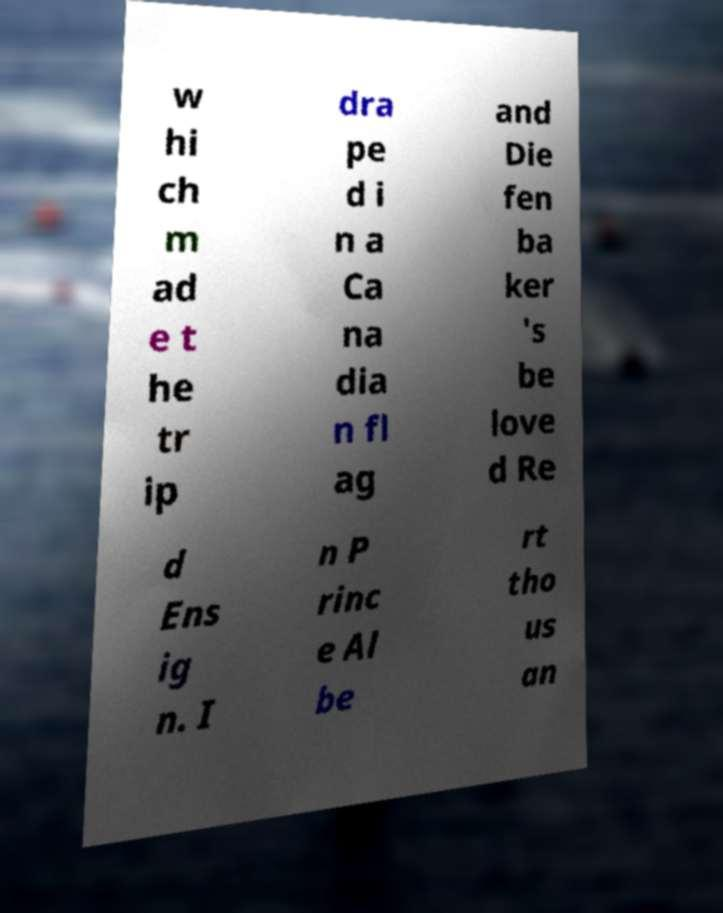Please identify and transcribe the text found in this image. w hi ch m ad e t he tr ip dra pe d i n a Ca na dia n fl ag and Die fen ba ker 's be love d Re d Ens ig n. I n P rinc e Al be rt tho us an 